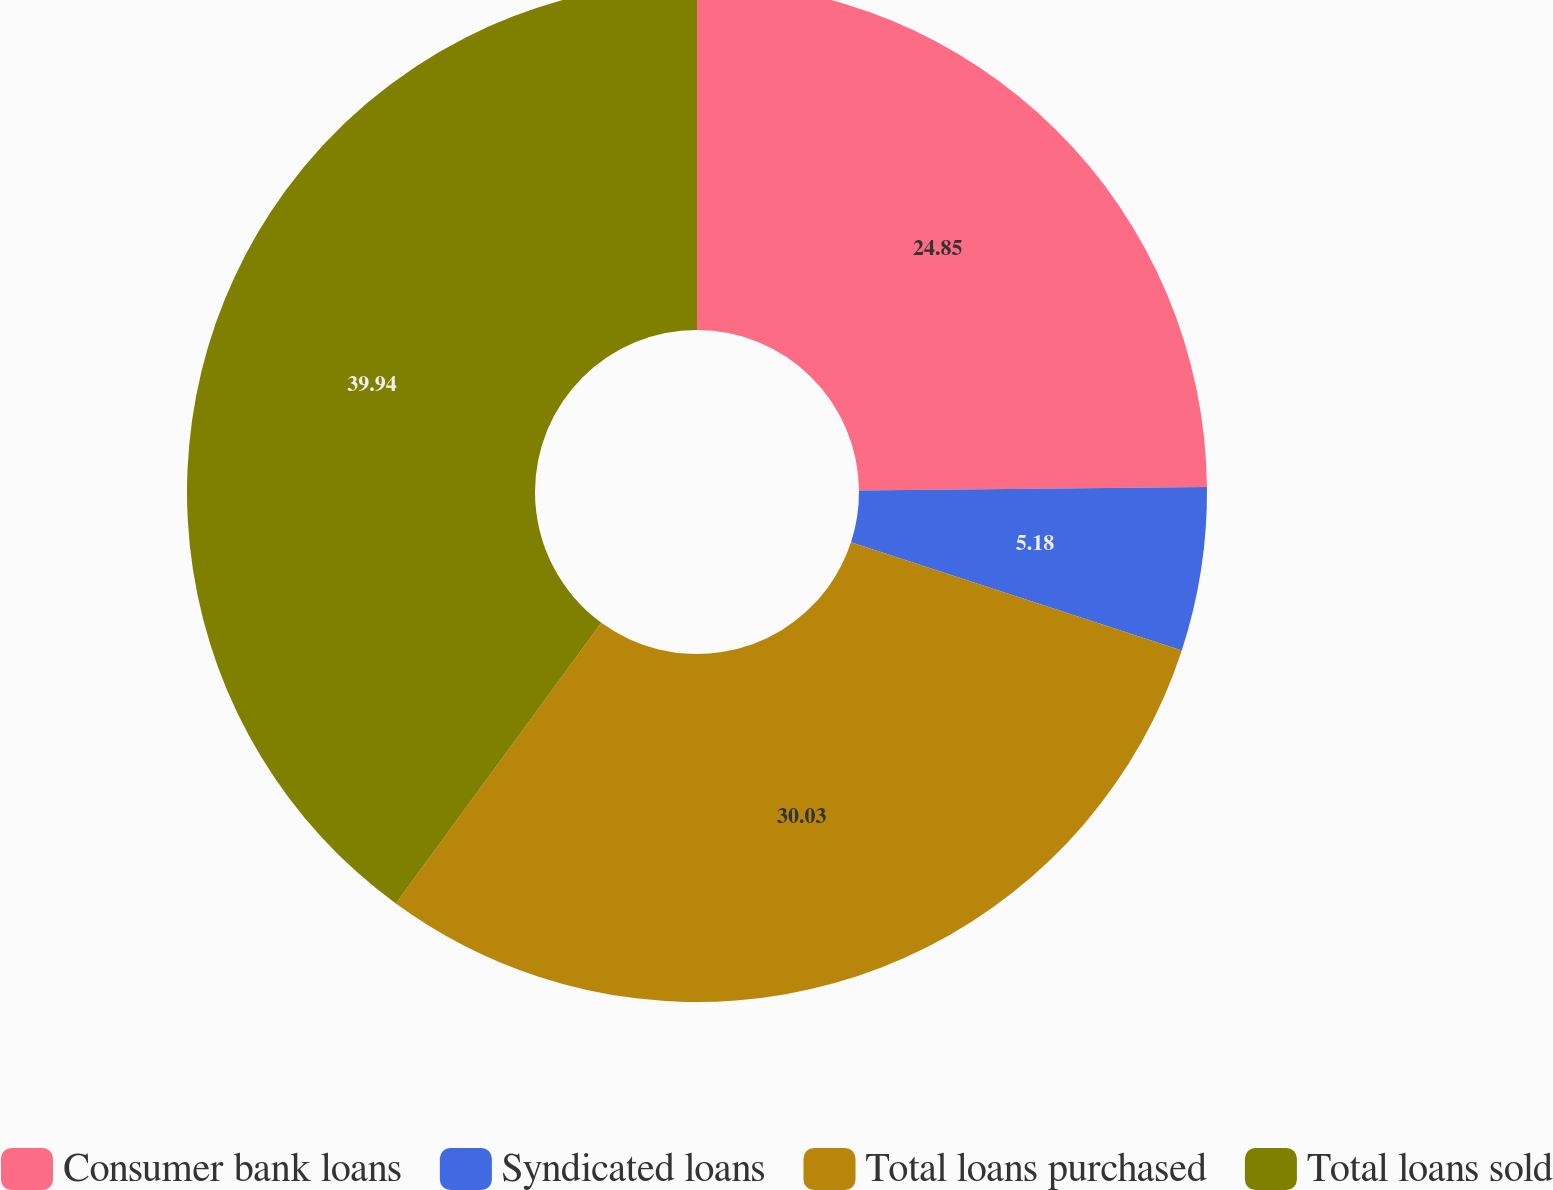<chart> <loc_0><loc_0><loc_500><loc_500><pie_chart><fcel>Consumer bank loans<fcel>Syndicated loans<fcel>Total loans purchased<fcel>Total loans sold<nl><fcel>24.85%<fcel>5.18%<fcel>30.03%<fcel>39.95%<nl></chart> 